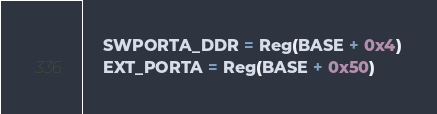<code> <loc_0><loc_0><loc_500><loc_500><_Python_>    SWPORTA_DDR = Reg(BASE + 0x4)
    EXT_PORTA = Reg(BASE + 0x50)</code> 